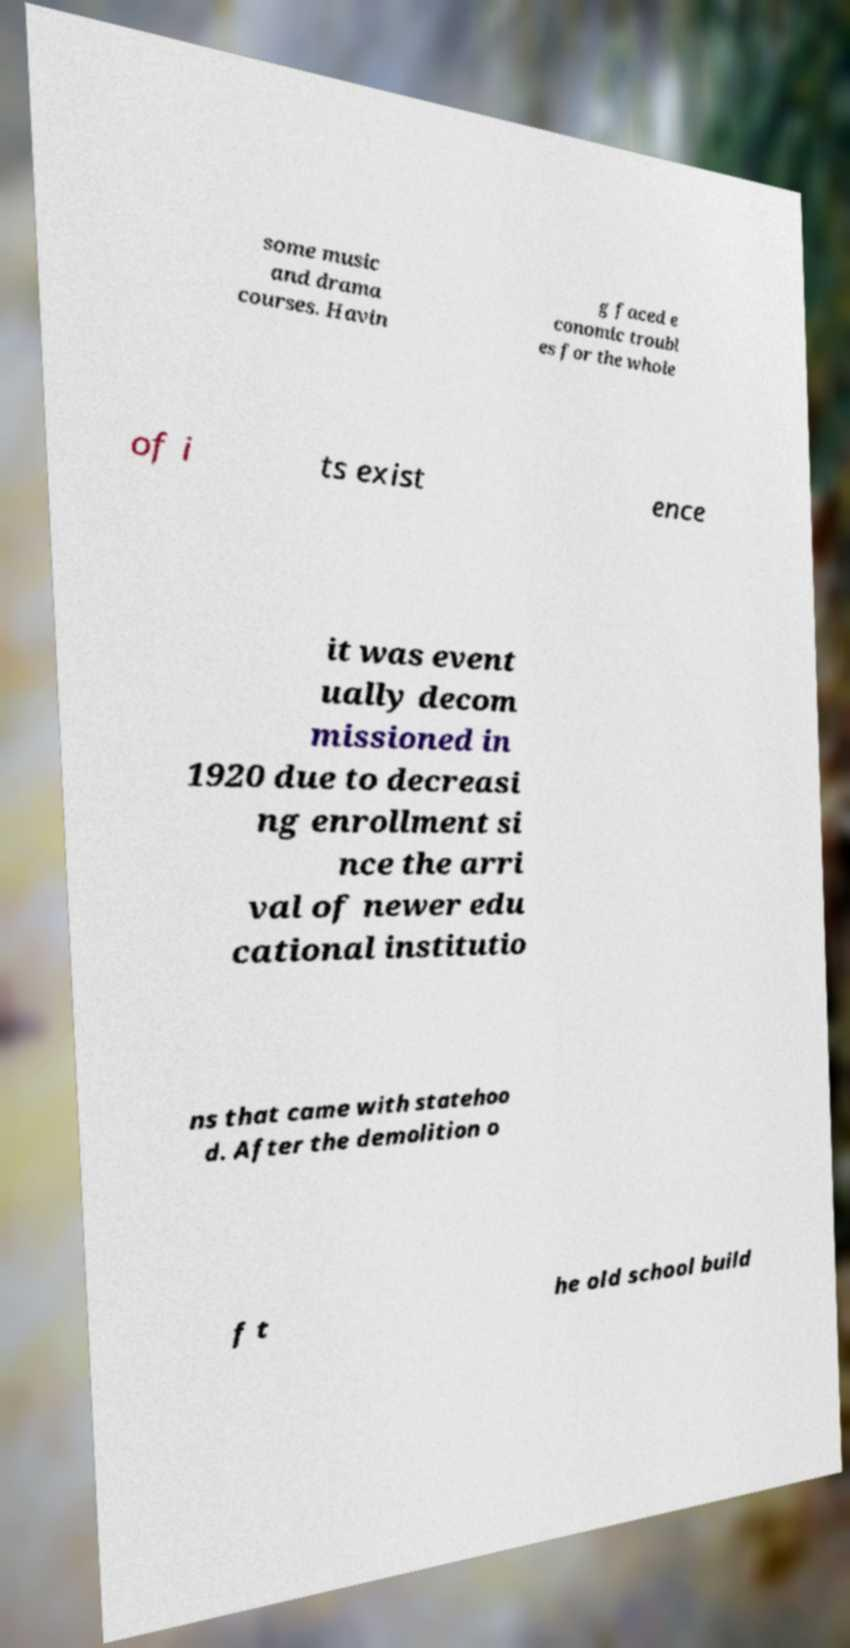For documentation purposes, I need the text within this image transcribed. Could you provide that? some music and drama courses. Havin g faced e conomic troubl es for the whole of i ts exist ence it was event ually decom missioned in 1920 due to decreasi ng enrollment si nce the arri val of newer edu cational institutio ns that came with statehoo d. After the demolition o f t he old school build 